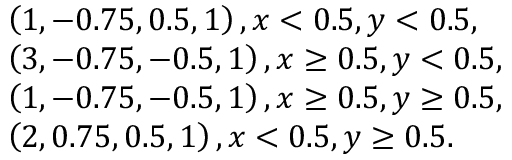Convert formula to latex. <formula><loc_0><loc_0><loc_500><loc_500>\begin{array} { r l } & { \left ( 1 , - 0 . 7 5 , 0 . 5 , 1 \right ) , x < 0 . 5 , y < 0 . 5 , } \\ & { \left ( 3 , - 0 . 7 5 , - 0 . 5 , 1 \right ) , x \geq 0 . 5 , y < 0 . 5 , } \\ & { \left ( 1 , - 0 . 7 5 , - 0 . 5 , 1 \right ) , x \geq 0 . 5 , y \geq 0 . 5 , } \\ & { \left ( 2 , 0 . 7 5 , 0 . 5 , 1 \right ) , x < 0 . 5 , y \geq 0 . 5 . } \end{array}</formula> 